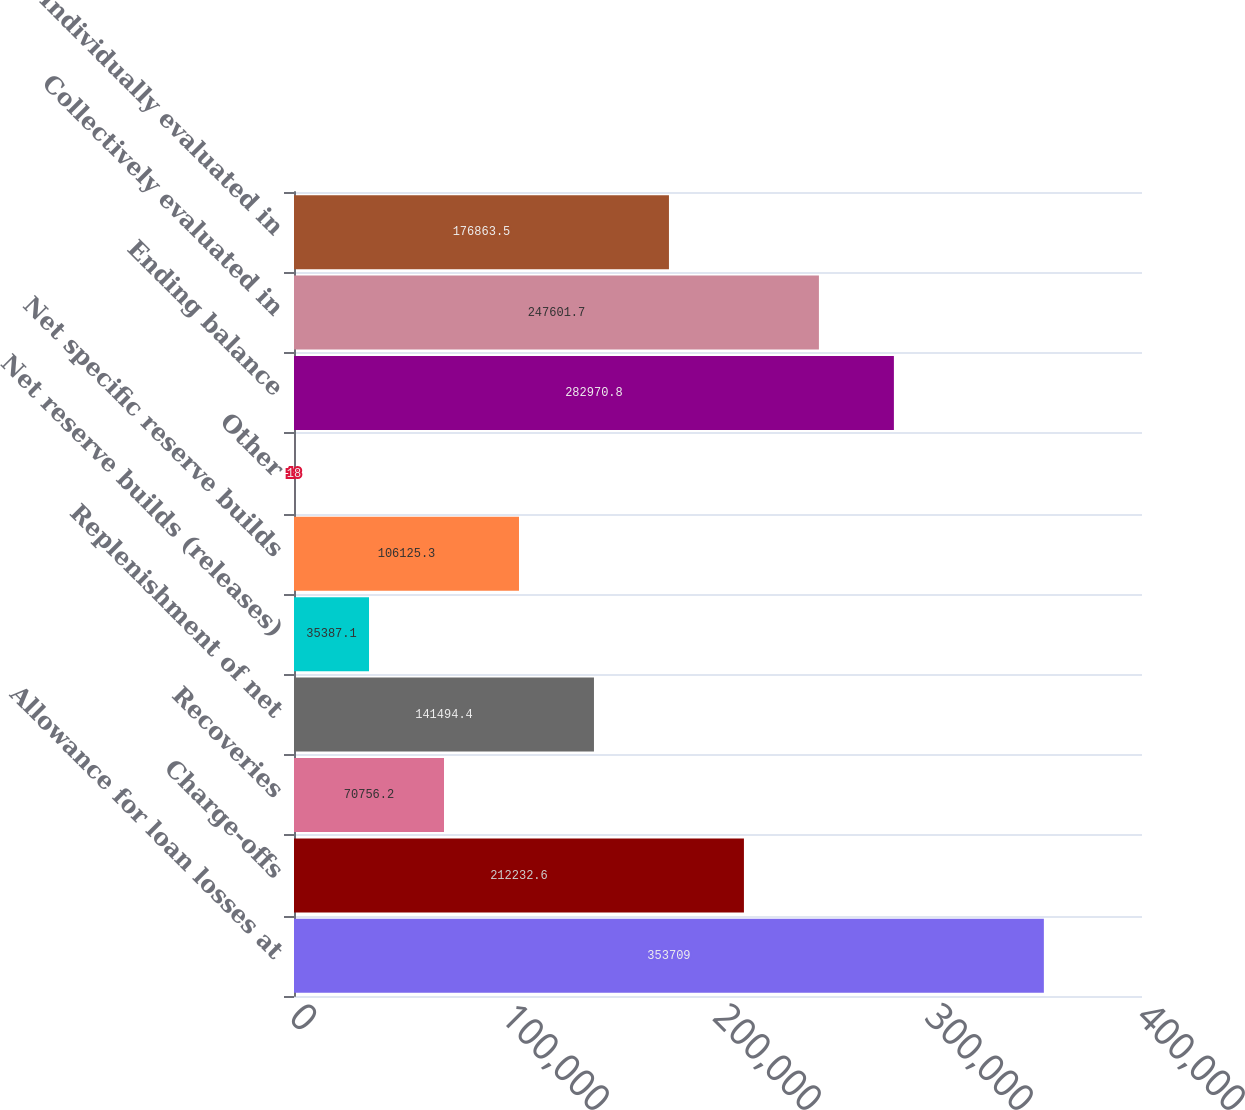Convert chart to OTSL. <chart><loc_0><loc_0><loc_500><loc_500><bar_chart><fcel>Allowance for loan losses at<fcel>Charge-offs<fcel>Recoveries<fcel>Replenishment of net<fcel>Net reserve builds (releases)<fcel>Net specific reserve builds<fcel>Other<fcel>Ending balance<fcel>Collectively evaluated in<fcel>Individually evaluated in<nl><fcel>353709<fcel>212233<fcel>70756.2<fcel>141494<fcel>35387.1<fcel>106125<fcel>18<fcel>282971<fcel>247602<fcel>176864<nl></chart> 